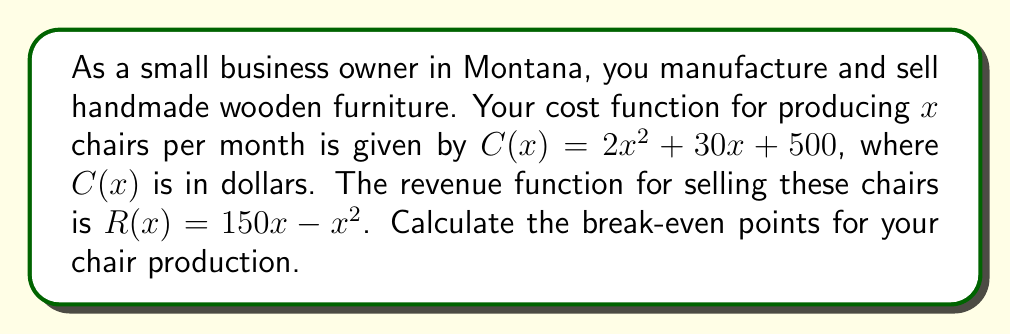Could you help me with this problem? To find the break-even points, we need to determine where the cost function equals the revenue function. This occurs when profit is zero.

1. Set up the profit equation:
   $P(x) = R(x) - C(x) = 0$
   $(150x - x^2) - (2x^2 + 30x + 500) = 0$

2. Simplify the equation:
   $150x - x^2 - 2x^2 - 30x - 500 = 0$
   $-3x^2 + 120x - 500 = 0$

3. This is a quadratic equation in standard form $ax^2 + bx + c = 0$, where:
   $a = -3$, $b = 120$, and $c = -500$

4. Use the quadratic formula: $x = \frac{-b \pm \sqrt{b^2 - 4ac}}{2a}$

5. Substitute the values:
   $x = \frac{-120 \pm \sqrt{120^2 - 4(-3)(-500)}}{2(-3)}$
   $x = \frac{-120 \pm \sqrt{14400 - 6000}}{-6}$
   $x = \frac{-120 \pm \sqrt{8400}}{-6}$
   $x = \frac{-120 \pm 91.65}{-6}$

6. Solve for both solutions:
   $x_1 = \frac{-120 + 91.65}{-6} \approx 4.73$
   $x_2 = \frac{-120 - 91.65}{-6} \approx 35.27$

7. Round to the nearest whole number, as fractional chairs don't make sense in this context.
Answer: The break-even points occur at approximately 5 chairs and 35 chairs per month. 